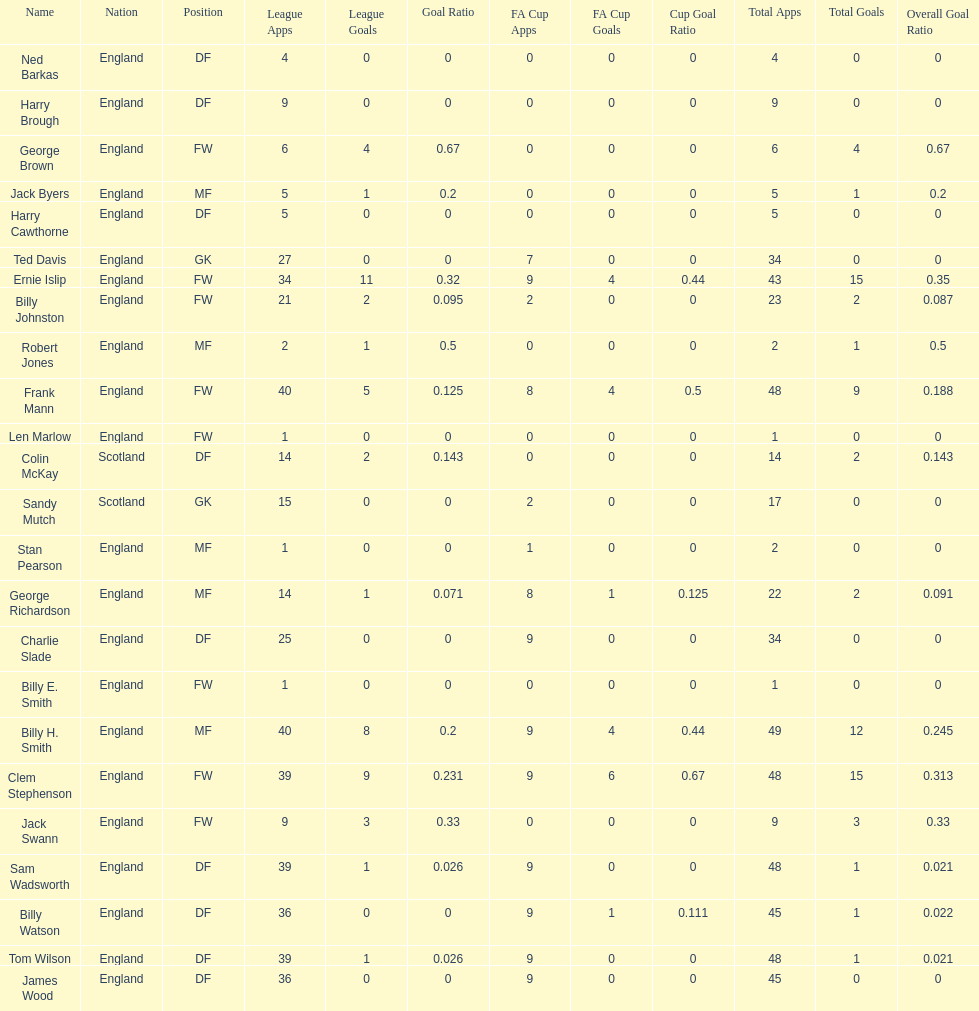Name the nation with the most appearances. England. 